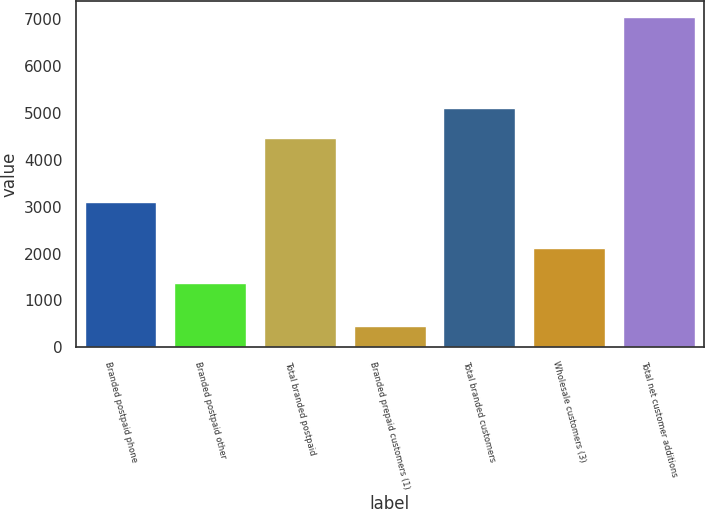Convert chart to OTSL. <chart><loc_0><loc_0><loc_500><loc_500><bar_chart><fcel>Branded postpaid phone<fcel>Branded postpaid other<fcel>Total branded postpaid<fcel>Branded prepaid customers (1)<fcel>Total branded customers<fcel>Wholesale customers (3)<fcel>Total net customer additions<nl><fcel>3097<fcel>1362<fcel>4459<fcel>460<fcel>5117.4<fcel>2125<fcel>7044<nl></chart> 